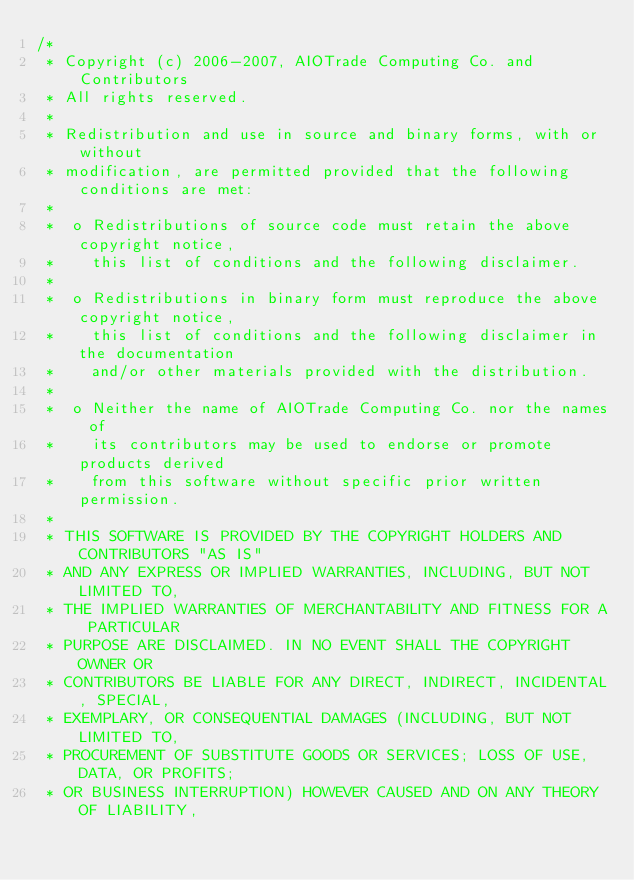Convert code to text. <code><loc_0><loc_0><loc_500><loc_500><_Scala_>/*
 * Copyright (c) 2006-2007, AIOTrade Computing Co. and Contributors
 * All rights reserved.
 * 
 * Redistribution and use in source and binary forms, with or without 
 * modification, are permitted provided that the following conditions are met:
 * 
 *  o Redistributions of source code must retain the above copyright notice, 
 *    this list of conditions and the following disclaimer. 
 *    
 *  o Redistributions in binary form must reproduce the above copyright notice, 
 *    this list of conditions and the following disclaimer in the documentation 
 *    and/or other materials provided with the distribution. 
 *    
 *  o Neither the name of AIOTrade Computing Co. nor the names of 
 *    its contributors may be used to endorse or promote products derived 
 *    from this software without specific prior written permission. 
 *    
 * THIS SOFTWARE IS PROVIDED BY THE COPYRIGHT HOLDERS AND CONTRIBUTORS "AS IS" 
 * AND ANY EXPRESS OR IMPLIED WARRANTIES, INCLUDING, BUT NOT LIMITED TO, 
 * THE IMPLIED WARRANTIES OF MERCHANTABILITY AND FITNESS FOR A PARTICULAR 
 * PURPOSE ARE DISCLAIMED. IN NO EVENT SHALL THE COPYRIGHT OWNER OR 
 * CONTRIBUTORS BE LIABLE FOR ANY DIRECT, INDIRECT, INCIDENTAL, SPECIAL, 
 * EXEMPLARY, OR CONSEQUENTIAL DAMAGES (INCLUDING, BUT NOT LIMITED TO, 
 * PROCUREMENT OF SUBSTITUTE GOODS OR SERVICES; LOSS OF USE, DATA, OR PROFITS; 
 * OR BUSINESS INTERRUPTION) HOWEVER CAUSED AND ON ANY THEORY OF LIABILITY, </code> 